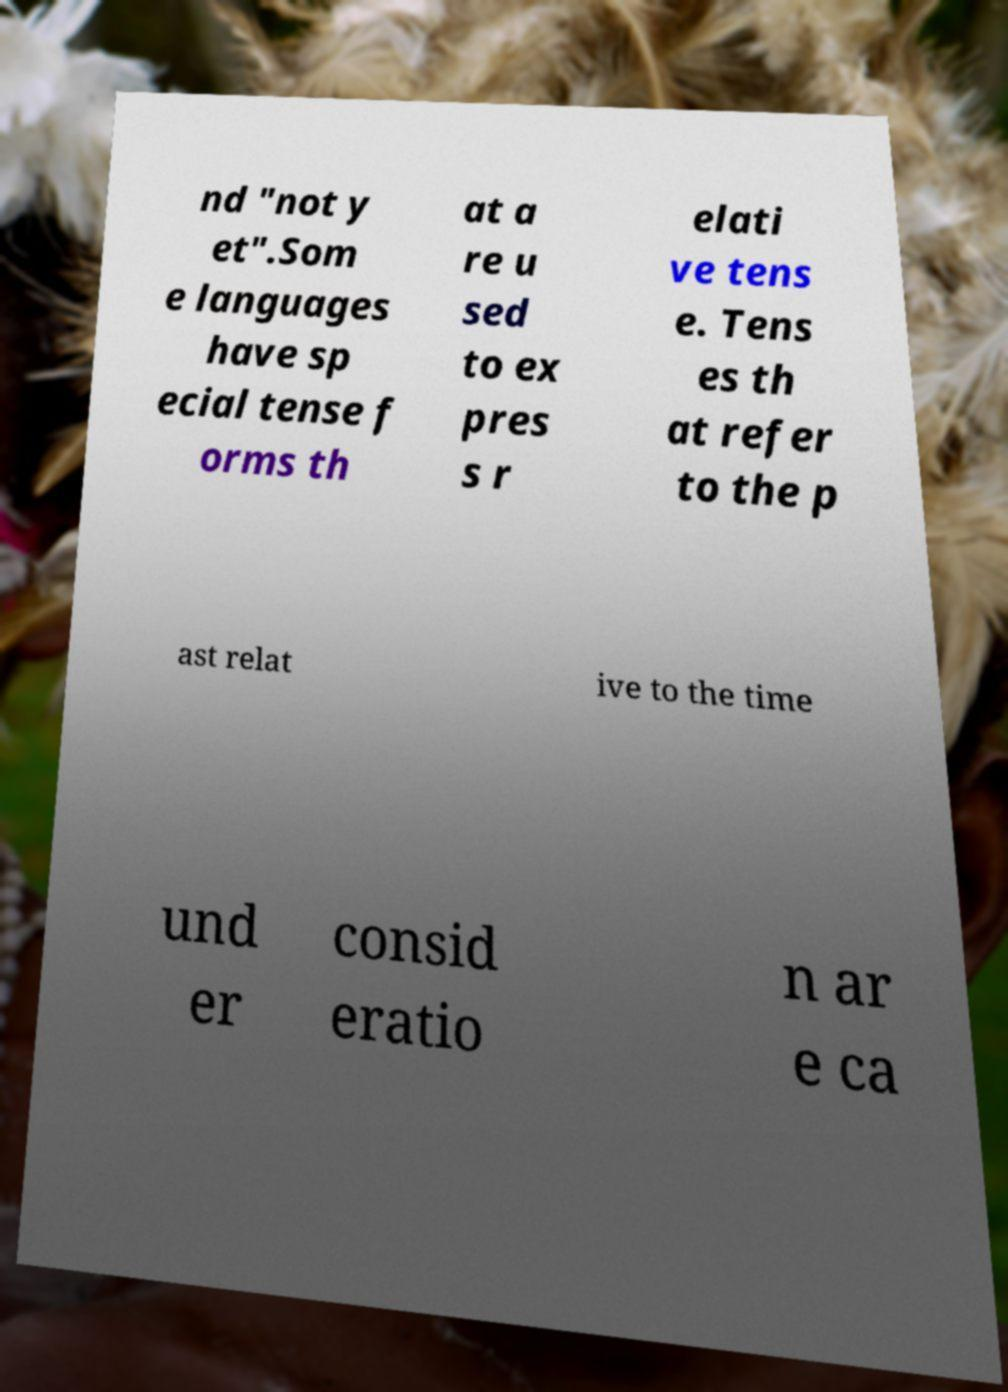I need the written content from this picture converted into text. Can you do that? nd "not y et".Som e languages have sp ecial tense f orms th at a re u sed to ex pres s r elati ve tens e. Tens es th at refer to the p ast relat ive to the time und er consid eratio n ar e ca 